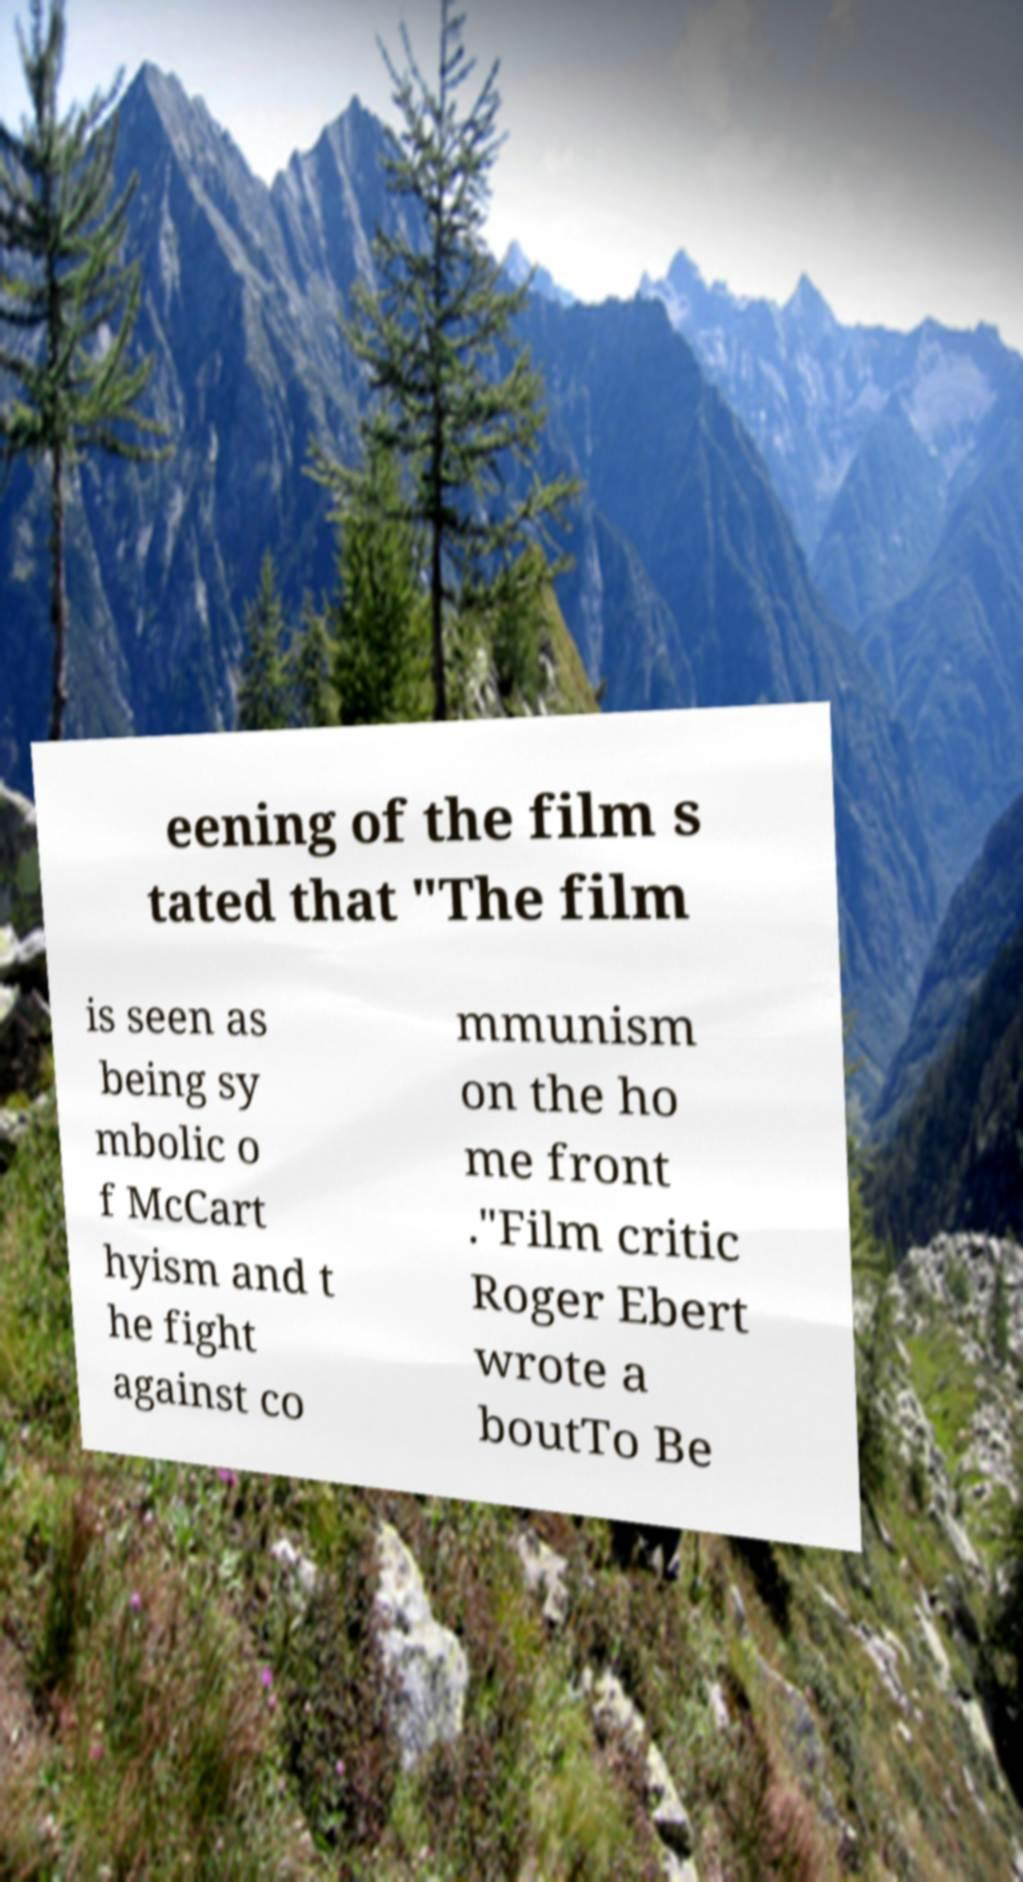Can you accurately transcribe the text from the provided image for me? eening of the film s tated that "The film is seen as being sy mbolic o f McCart hyism and t he fight against co mmunism on the ho me front ."Film critic Roger Ebert wrote a boutTo Be 